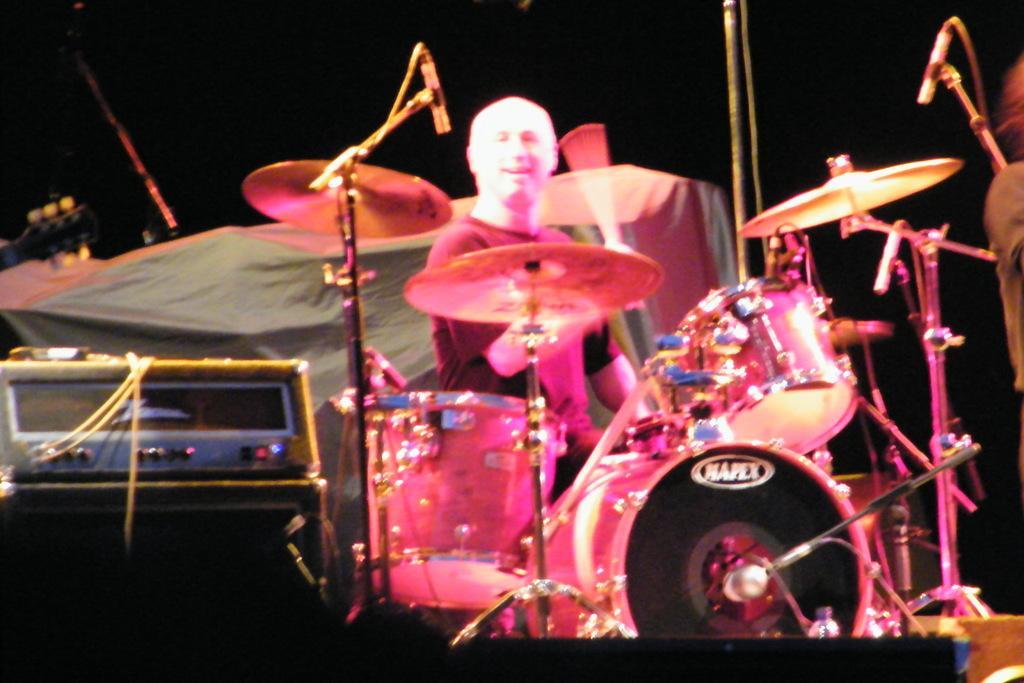Describe this image in one or two sentences. In this image we can see a man is playing drums. We can see a black color box and an electronic device on the left side of the image. In the background, there is one object. 